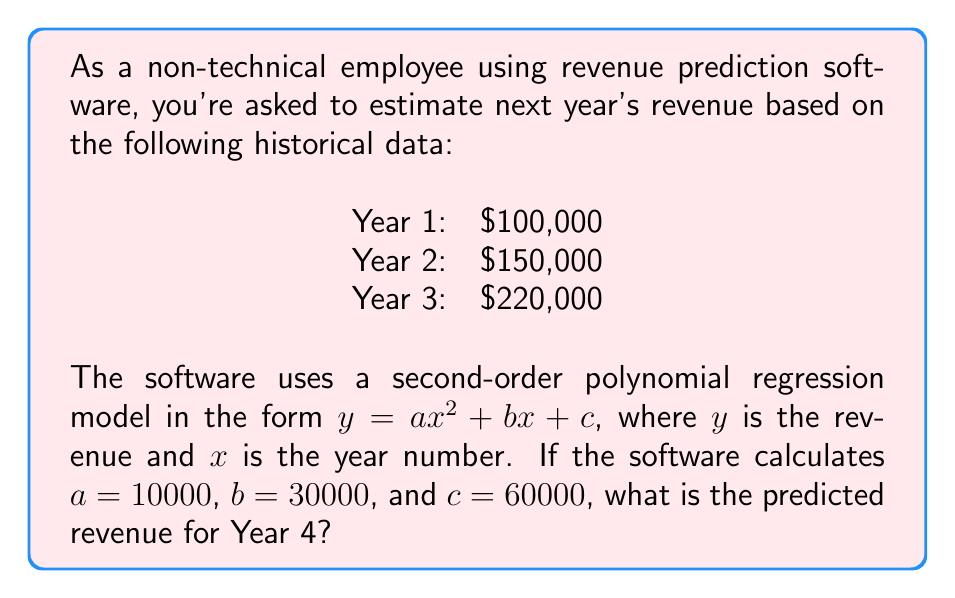Could you help me with this problem? To solve this problem, we'll follow these steps:

1. Understand the given second-order polynomial regression model:
   $y = ax^2 + bx + c$
   where $y$ is the revenue, $x$ is the year number, and $a$, $b$, and $c$ are the coefficients determined by the software.

2. Substitute the given values:
   $a = 10000$
   $b = 30000$
   $c = 60000$

3. Our equation becomes:
   $y = 10000x^2 + 30000x + 60000$

4. To predict the revenue for Year 4, we need to substitute $x = 4$ into the equation:

   $y = 10000(4)^2 + 30000(4) + 60000$

5. Calculate step by step:
   $y = 10000(16) + 30000(4) + 60000$
   $y = 160000 + 120000 + 60000$
   $y = 340000$

Therefore, the predicted revenue for Year 4 is $340,000.
Answer: $340,000 